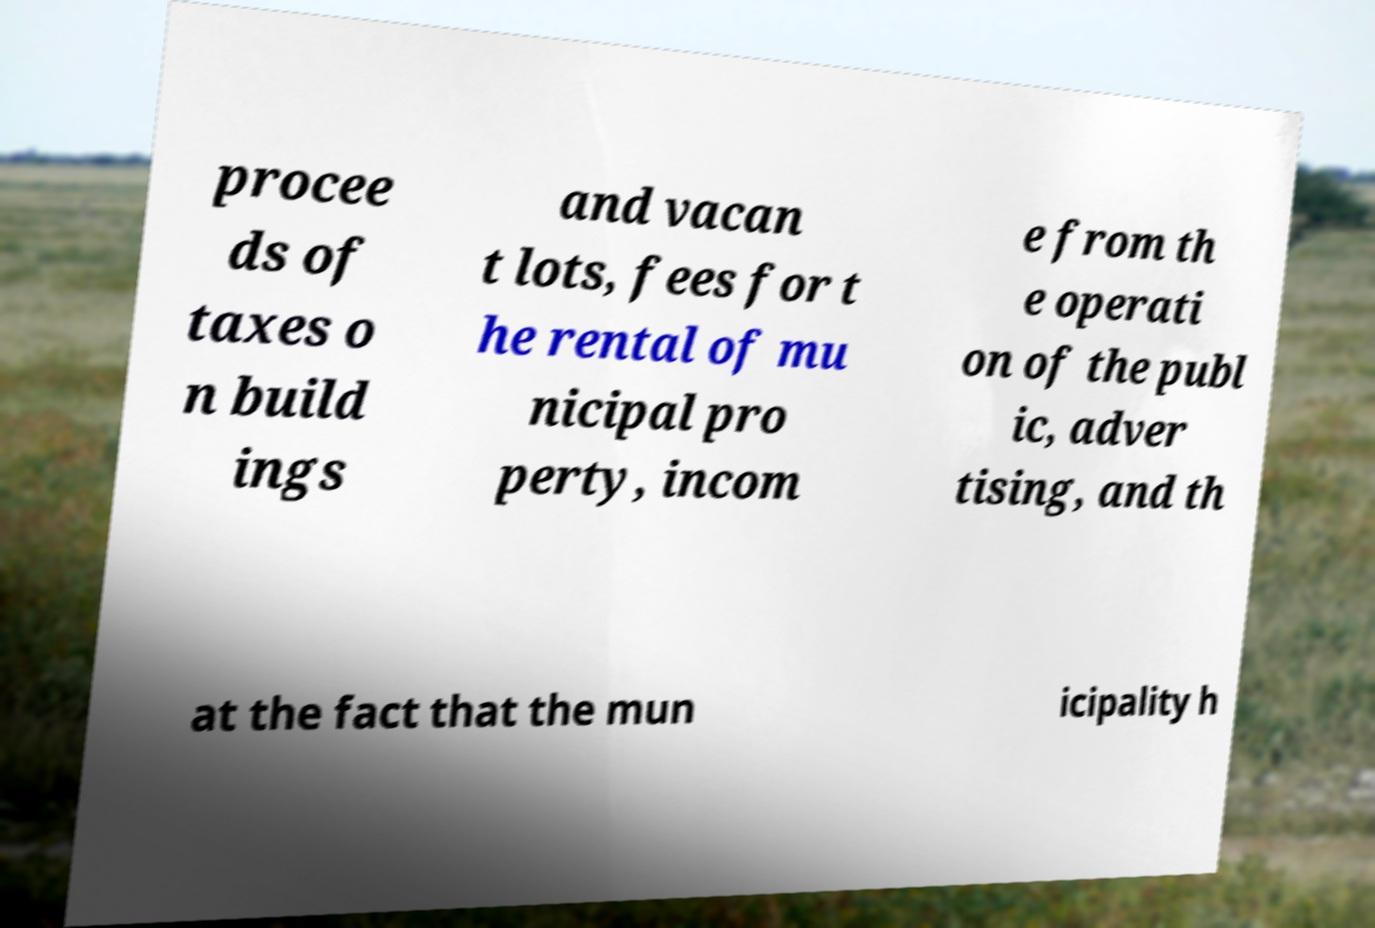There's text embedded in this image that I need extracted. Can you transcribe it verbatim? procee ds of taxes o n build ings and vacan t lots, fees for t he rental of mu nicipal pro perty, incom e from th e operati on of the publ ic, adver tising, and th at the fact that the mun icipality h 